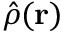<formula> <loc_0><loc_0><loc_500><loc_500>\hat { \rho } ( { r } )</formula> 